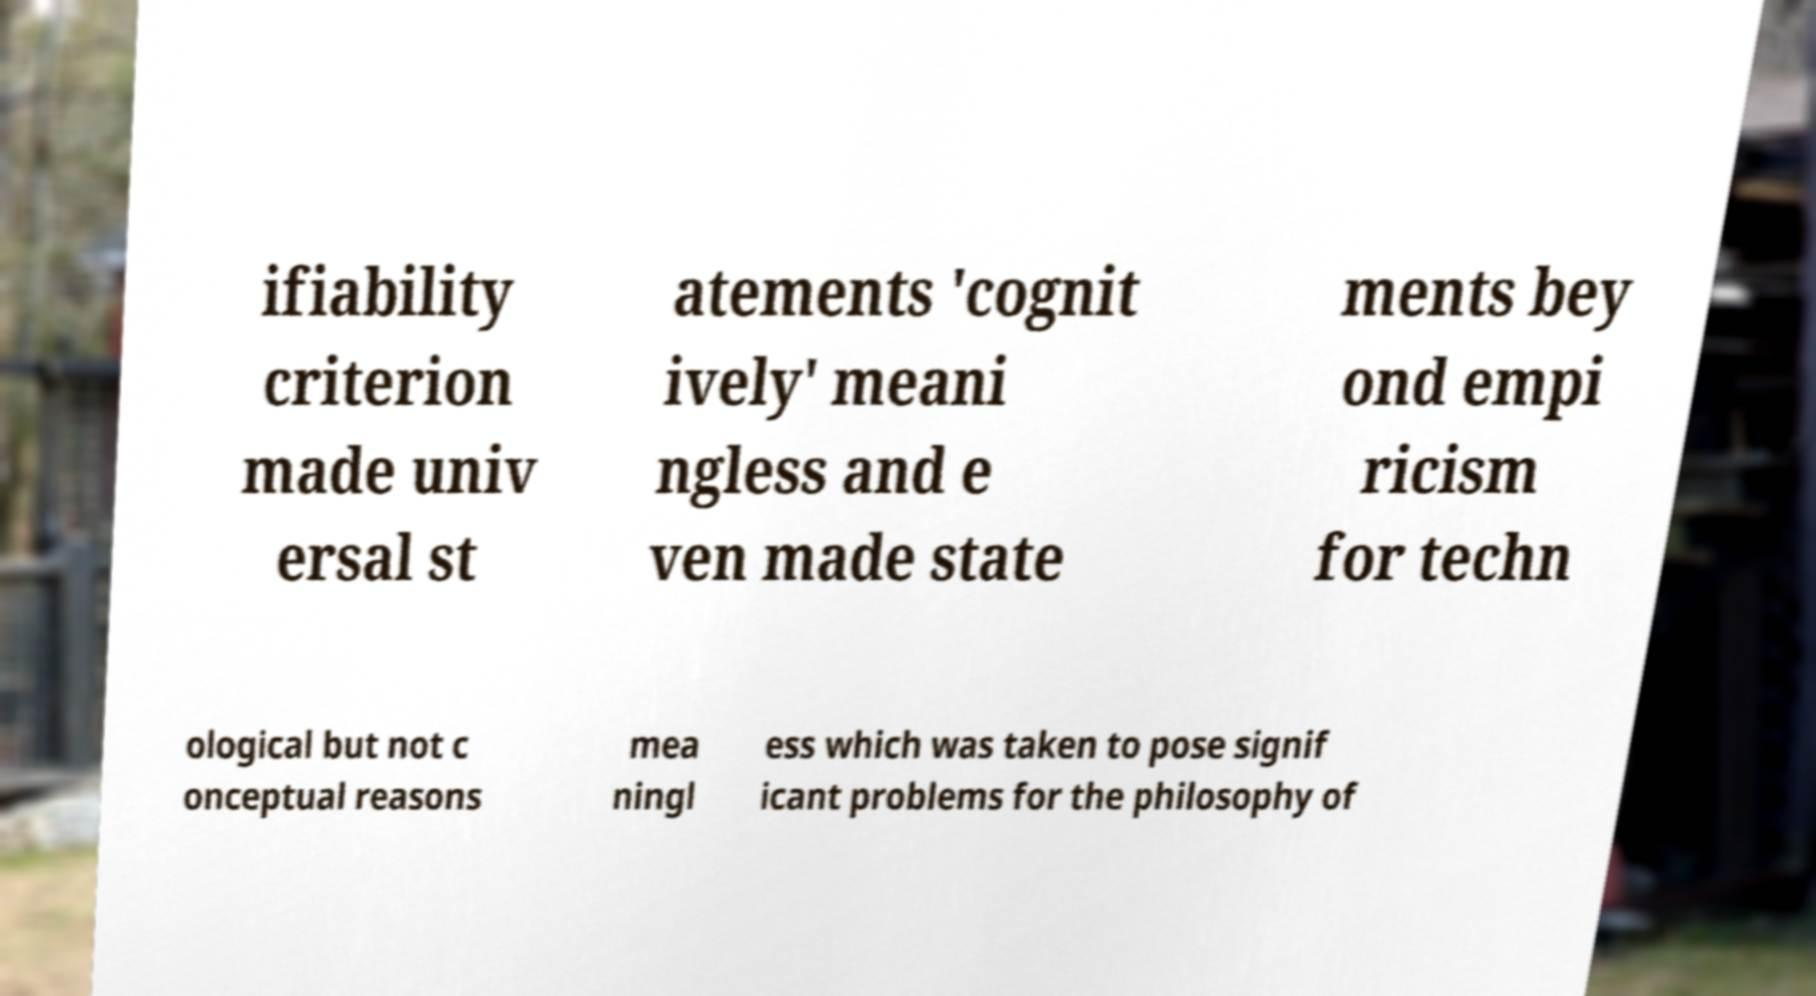Can you read and provide the text displayed in the image?This photo seems to have some interesting text. Can you extract and type it out for me? ifiability criterion made univ ersal st atements 'cognit ively' meani ngless and e ven made state ments bey ond empi ricism for techn ological but not c onceptual reasons mea ningl ess which was taken to pose signif icant problems for the philosophy of 